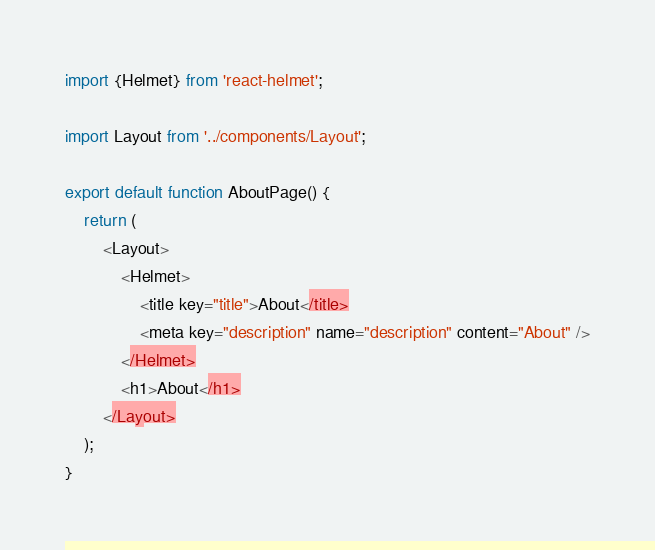<code> <loc_0><loc_0><loc_500><loc_500><_JavaScript_>import {Helmet} from 'react-helmet';

import Layout from '../components/Layout';

export default function AboutPage() {
	return (
		<Layout>
			<Helmet>
				<title key="title">About</title>
				<meta key="description" name="description" content="About" />
			</Helmet>
			<h1>About</h1>
		</Layout>
	);
}
</code> 